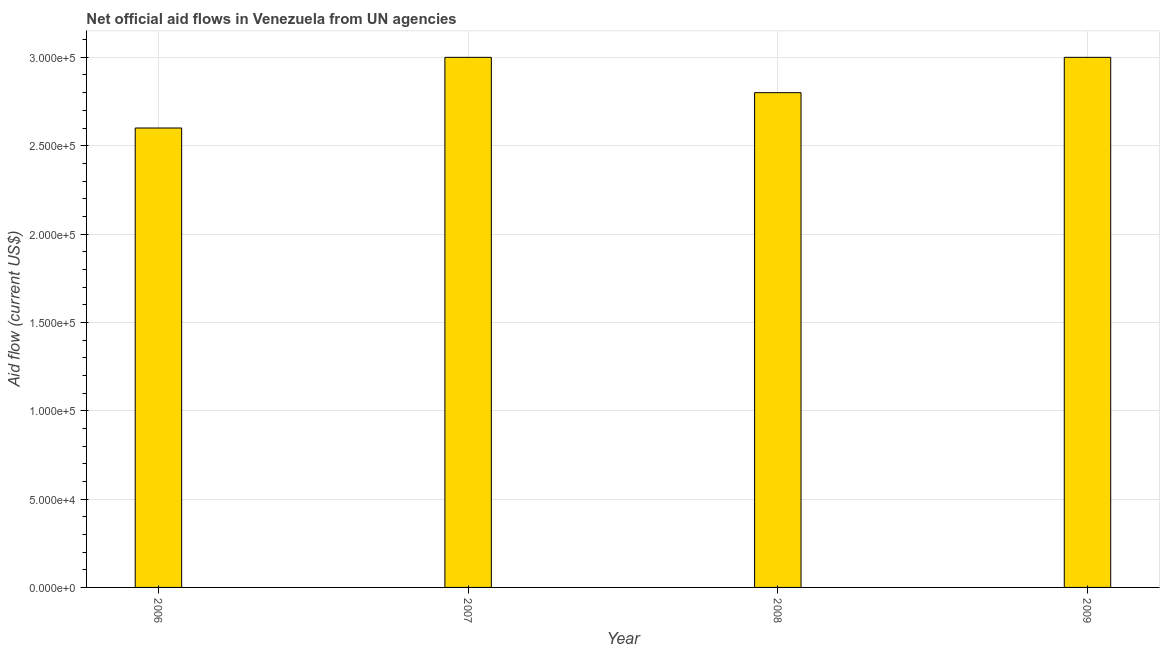What is the title of the graph?
Offer a very short reply. Net official aid flows in Venezuela from UN agencies. What is the label or title of the X-axis?
Provide a succinct answer. Year. What is the net official flows from un agencies in 2007?
Your response must be concise. 3.00e+05. In which year was the net official flows from un agencies maximum?
Keep it short and to the point. 2007. In which year was the net official flows from un agencies minimum?
Offer a very short reply. 2006. What is the sum of the net official flows from un agencies?
Provide a short and direct response. 1.14e+06. What is the difference between the net official flows from un agencies in 2006 and 2008?
Your answer should be very brief. -2.00e+04. What is the average net official flows from un agencies per year?
Provide a succinct answer. 2.85e+05. What is the median net official flows from un agencies?
Your answer should be compact. 2.90e+05. In how many years, is the net official flows from un agencies greater than 170000 US$?
Your answer should be compact. 4. What is the ratio of the net official flows from un agencies in 2007 to that in 2008?
Provide a succinct answer. 1.07. Is the net official flows from un agencies in 2006 less than that in 2008?
Give a very brief answer. Yes. Is the difference between the net official flows from un agencies in 2006 and 2008 greater than the difference between any two years?
Keep it short and to the point. No. What is the difference between the highest and the second highest net official flows from un agencies?
Provide a short and direct response. 0. In how many years, is the net official flows from un agencies greater than the average net official flows from un agencies taken over all years?
Provide a short and direct response. 2. How many bars are there?
Make the answer very short. 4. How many years are there in the graph?
Your answer should be compact. 4. What is the difference between two consecutive major ticks on the Y-axis?
Keep it short and to the point. 5.00e+04. Are the values on the major ticks of Y-axis written in scientific E-notation?
Give a very brief answer. Yes. What is the Aid flow (current US$) in 2007?
Your answer should be compact. 3.00e+05. What is the Aid flow (current US$) in 2009?
Give a very brief answer. 3.00e+05. What is the difference between the Aid flow (current US$) in 2006 and 2008?
Your answer should be compact. -2.00e+04. What is the difference between the Aid flow (current US$) in 2006 and 2009?
Keep it short and to the point. -4.00e+04. What is the difference between the Aid flow (current US$) in 2007 and 2009?
Provide a succinct answer. 0. What is the difference between the Aid flow (current US$) in 2008 and 2009?
Offer a very short reply. -2.00e+04. What is the ratio of the Aid flow (current US$) in 2006 to that in 2007?
Give a very brief answer. 0.87. What is the ratio of the Aid flow (current US$) in 2006 to that in 2008?
Make the answer very short. 0.93. What is the ratio of the Aid flow (current US$) in 2006 to that in 2009?
Make the answer very short. 0.87. What is the ratio of the Aid flow (current US$) in 2007 to that in 2008?
Provide a succinct answer. 1.07. What is the ratio of the Aid flow (current US$) in 2007 to that in 2009?
Make the answer very short. 1. What is the ratio of the Aid flow (current US$) in 2008 to that in 2009?
Your response must be concise. 0.93. 